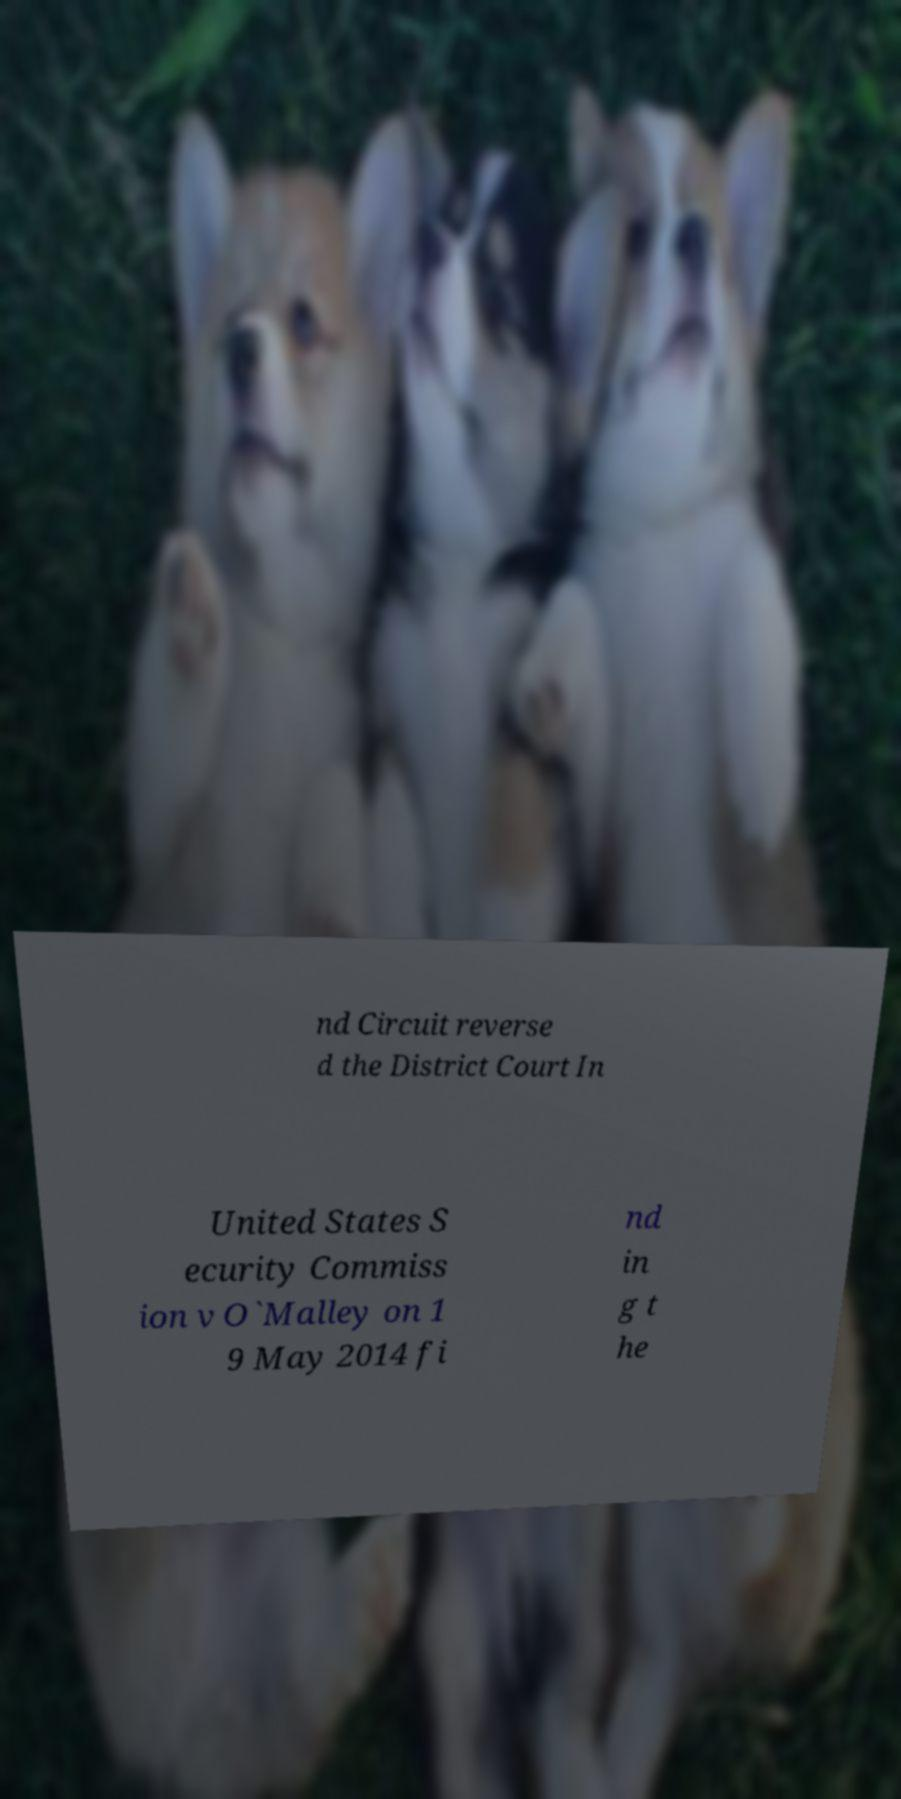Can you read and provide the text displayed in the image?This photo seems to have some interesting text. Can you extract and type it out for me? nd Circuit reverse d the District Court In United States S ecurity Commiss ion v O`Malley on 1 9 May 2014 fi nd in g t he 